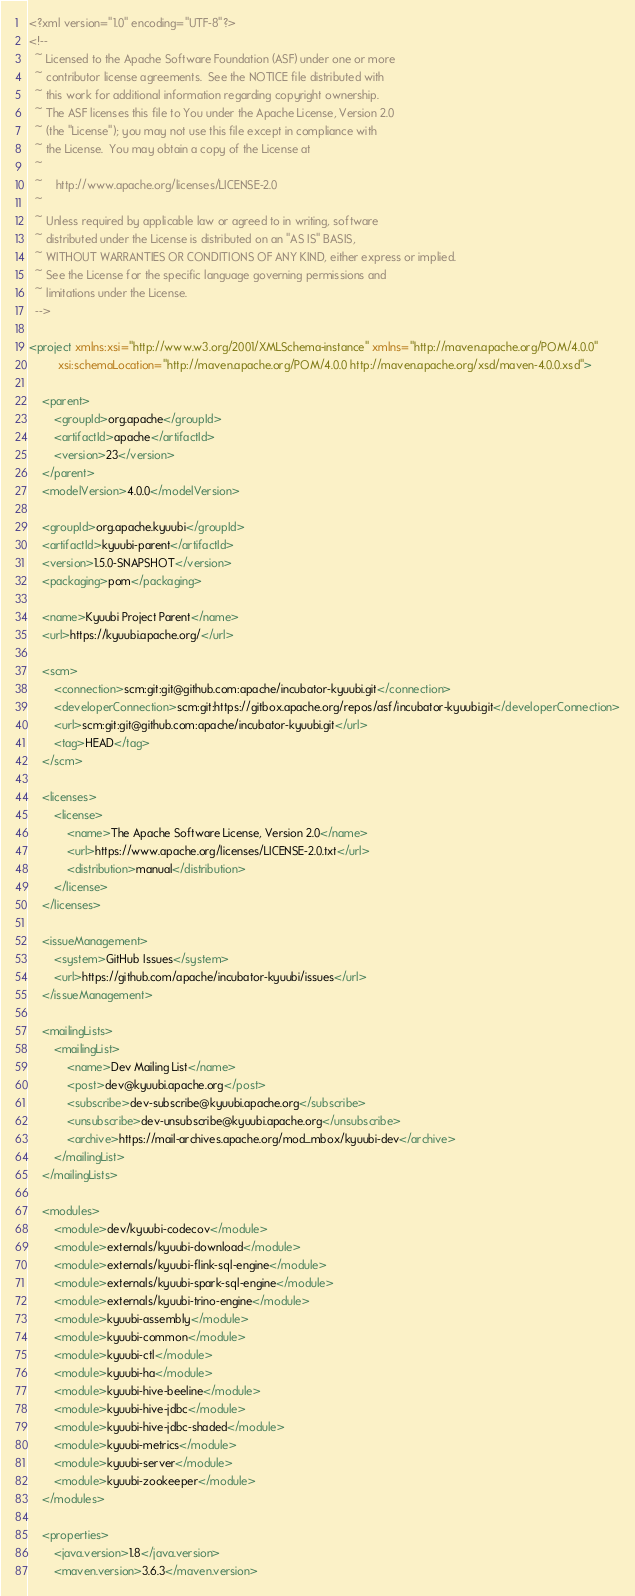Convert code to text. <code><loc_0><loc_0><loc_500><loc_500><_XML_><?xml version="1.0" encoding="UTF-8"?>
<!--
  ~ Licensed to the Apache Software Foundation (ASF) under one or more
  ~ contributor license agreements.  See the NOTICE file distributed with
  ~ this work for additional information regarding copyright ownership.
  ~ The ASF licenses this file to You under the Apache License, Version 2.0
  ~ (the "License"); you may not use this file except in compliance with
  ~ the License.  You may obtain a copy of the License at
  ~
  ~    http://www.apache.org/licenses/LICENSE-2.0
  ~
  ~ Unless required by applicable law or agreed to in writing, software
  ~ distributed under the License is distributed on an "AS IS" BASIS,
  ~ WITHOUT WARRANTIES OR CONDITIONS OF ANY KIND, either express or implied.
  ~ See the License for the specific language governing permissions and
  ~ limitations under the License.
  -->

<project xmlns:xsi="http://www.w3.org/2001/XMLSchema-instance" xmlns="http://maven.apache.org/POM/4.0.0"
         xsi:schemaLocation="http://maven.apache.org/POM/4.0.0 http://maven.apache.org/xsd/maven-4.0.0.xsd">

    <parent>
        <groupId>org.apache</groupId>
        <artifactId>apache</artifactId>
        <version>23</version>
    </parent>
    <modelVersion>4.0.0</modelVersion>

    <groupId>org.apache.kyuubi</groupId>
    <artifactId>kyuubi-parent</artifactId>
    <version>1.5.0-SNAPSHOT</version>
    <packaging>pom</packaging>

    <name>Kyuubi Project Parent</name>
    <url>https://kyuubi.apache.org/</url>

    <scm>
        <connection>scm:git:git@github.com:apache/incubator-kyuubi.git</connection>
        <developerConnection>scm:git:https://gitbox.apache.org/repos/asf/incubator-kyuubi.git</developerConnection>
        <url>scm:git:git@github.com:apache/incubator-kyuubi.git</url>
        <tag>HEAD</tag>
    </scm>

    <licenses>
        <license>
            <name>The Apache Software License, Version 2.0</name>
            <url>https://www.apache.org/licenses/LICENSE-2.0.txt</url>
            <distribution>manual</distribution>
        </license>
    </licenses>

    <issueManagement>
        <system>GitHub Issues</system>
        <url>https://github.com/apache/incubator-kyuubi/issues</url>
    </issueManagement>

    <mailingLists>
        <mailingList>
            <name>Dev Mailing List</name>
            <post>dev@kyuubi.apache.org</post>
            <subscribe>dev-subscribe@kyuubi.apache.org</subscribe>
            <unsubscribe>dev-unsubscribe@kyuubi.apache.org</unsubscribe>
            <archive>https://mail-archives.apache.org/mod_mbox/kyuubi-dev</archive>
        </mailingList>
    </mailingLists>

    <modules>
        <module>dev/kyuubi-codecov</module>
        <module>externals/kyuubi-download</module>
        <module>externals/kyuubi-flink-sql-engine</module>
        <module>externals/kyuubi-spark-sql-engine</module>
        <module>externals/kyuubi-trino-engine</module>
        <module>kyuubi-assembly</module>
        <module>kyuubi-common</module>
        <module>kyuubi-ctl</module>
        <module>kyuubi-ha</module>
        <module>kyuubi-hive-beeline</module>
        <module>kyuubi-hive-jdbc</module>
        <module>kyuubi-hive-jdbc-shaded</module>
        <module>kyuubi-metrics</module>
        <module>kyuubi-server</module>
        <module>kyuubi-zookeeper</module>
    </modules>

    <properties>
        <java.version>1.8</java.version>
        <maven.version>3.6.3</maven.version></code> 